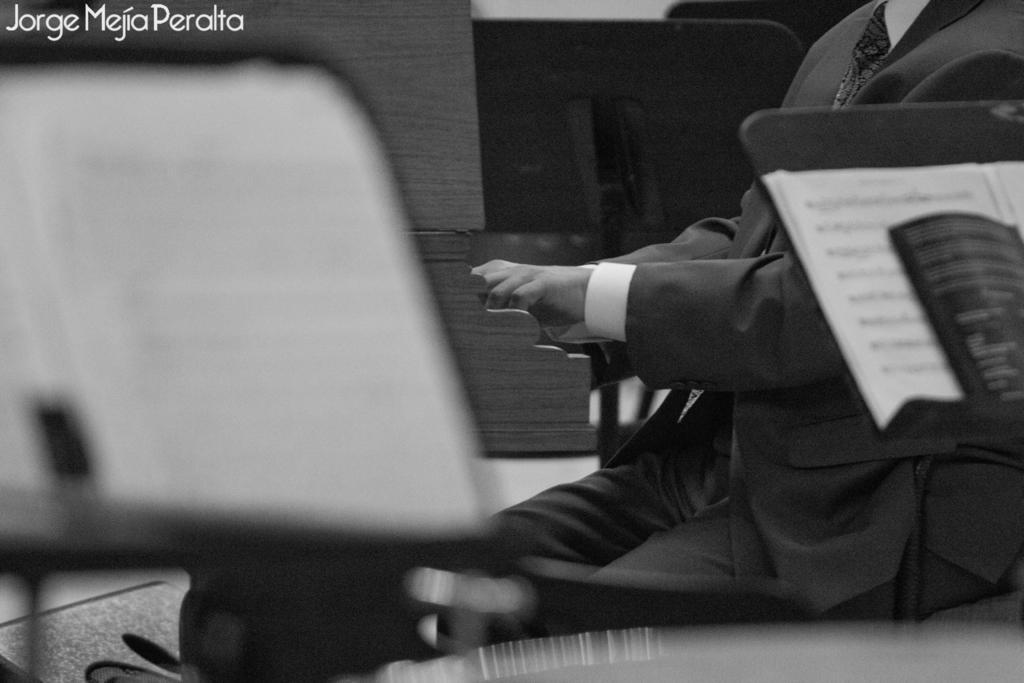How would you summarize this image in a sentence or two? This image consists of a man wearing a black suit and a white shirt. On the left and right, we can see book stands. At the bottom, there is a floor. In the background, there are wooden pieces. 